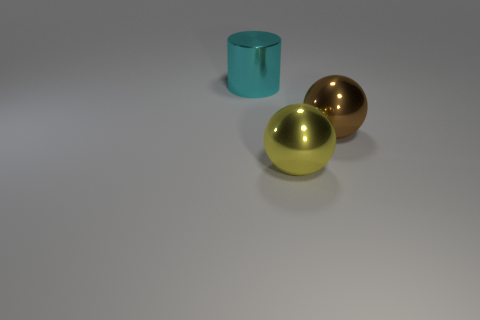Which objects in the picture are reflective? The two spherical objects exhibit reflective surfaces, as you can observe subtle highlights and distortions that suggest they interact with the light and the environment around them by mirroring it. 